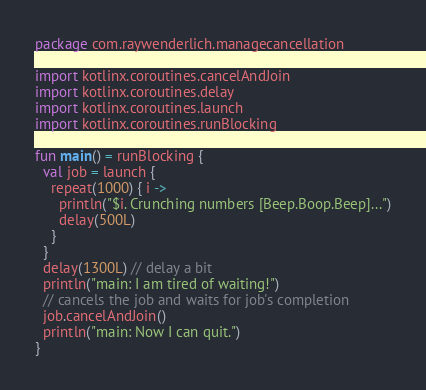Convert code to text. <code><loc_0><loc_0><loc_500><loc_500><_Kotlin_>package com.raywenderlich.managecancellation

import kotlinx.coroutines.cancelAndJoin
import kotlinx.coroutines.delay
import kotlinx.coroutines.launch
import kotlinx.coroutines.runBlocking

fun main() = runBlocking {
  val job = launch {
    repeat(1000) { i ->
      println("$i. Crunching numbers [Beep.Boop.Beep]...")
      delay(500L)
    }
  }
  delay(1300L) // delay a bit
  println("main: I am tired of waiting!")
  // cancels the job and waits for job's completion
  job.cancelAndJoin()
  println("main: Now I can quit.")
}</code> 